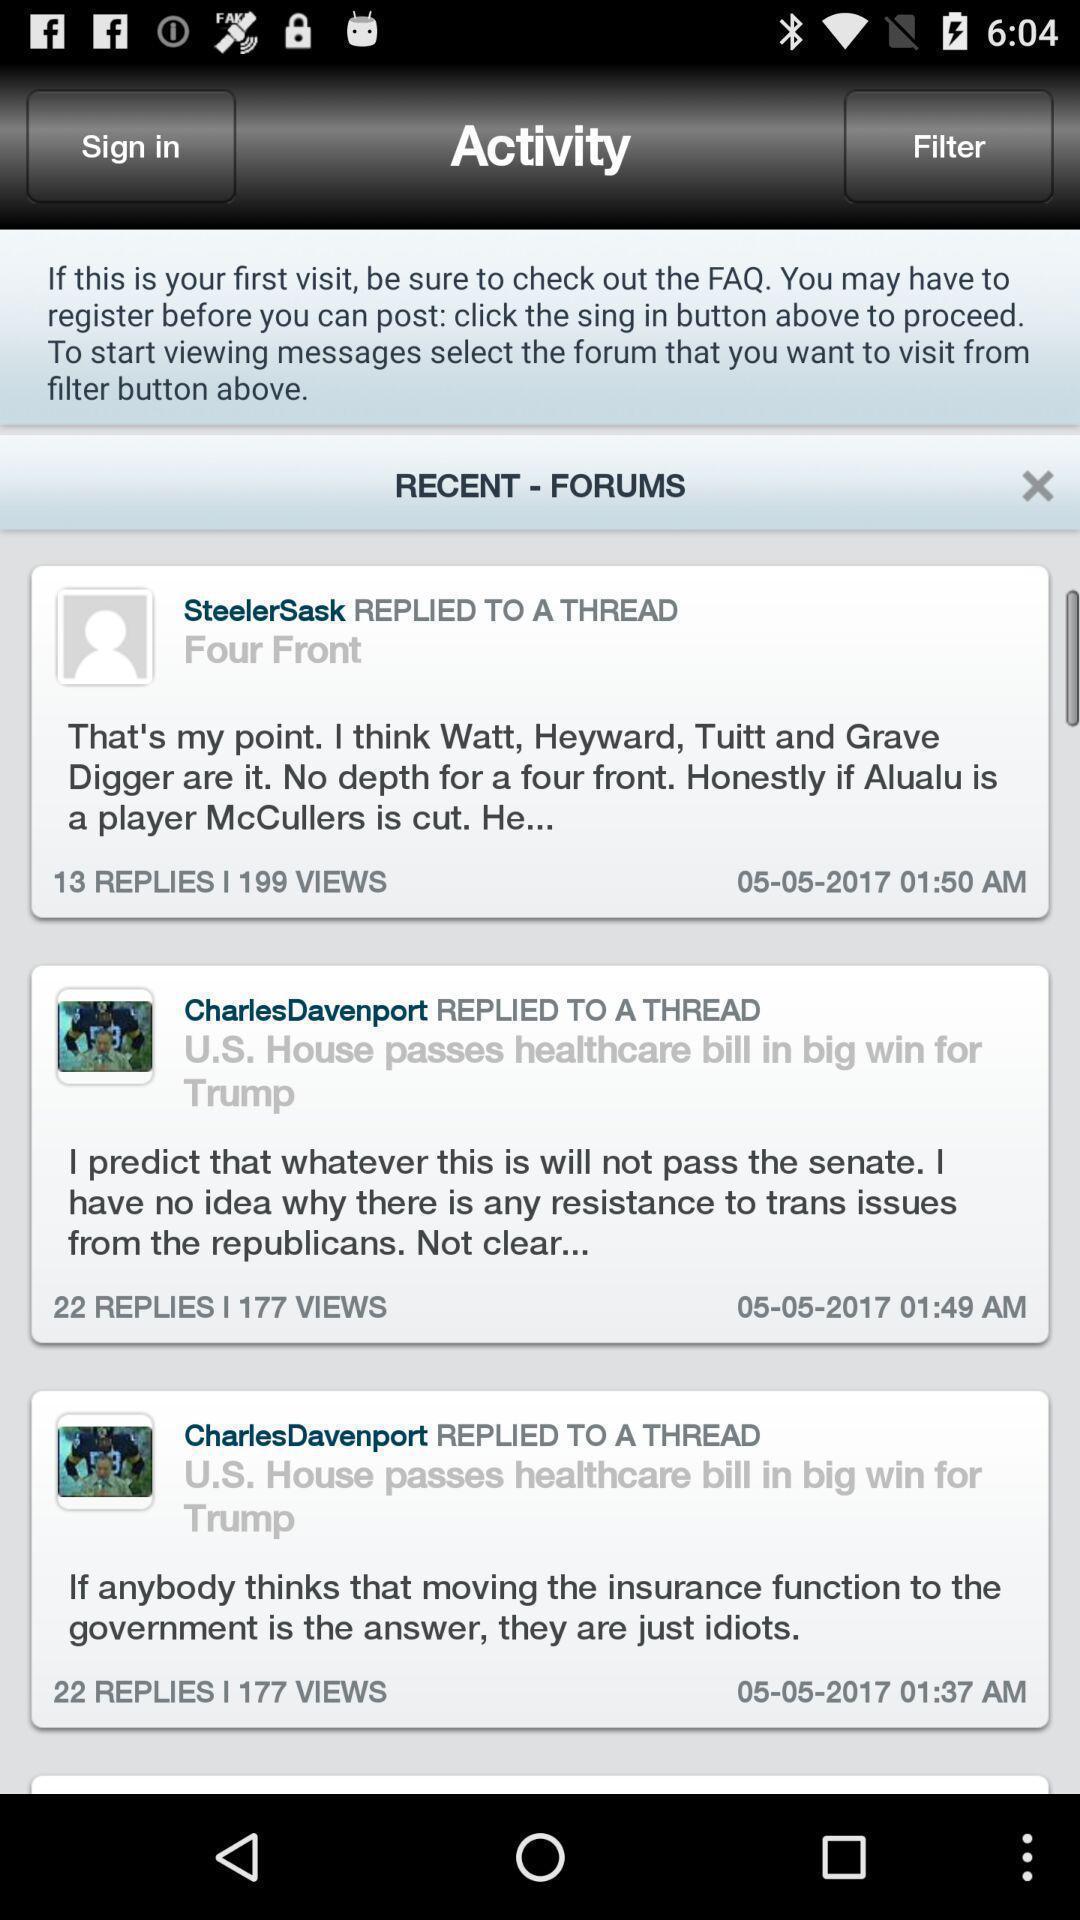Describe the key features of this screenshot. Window displaying list of activities. 